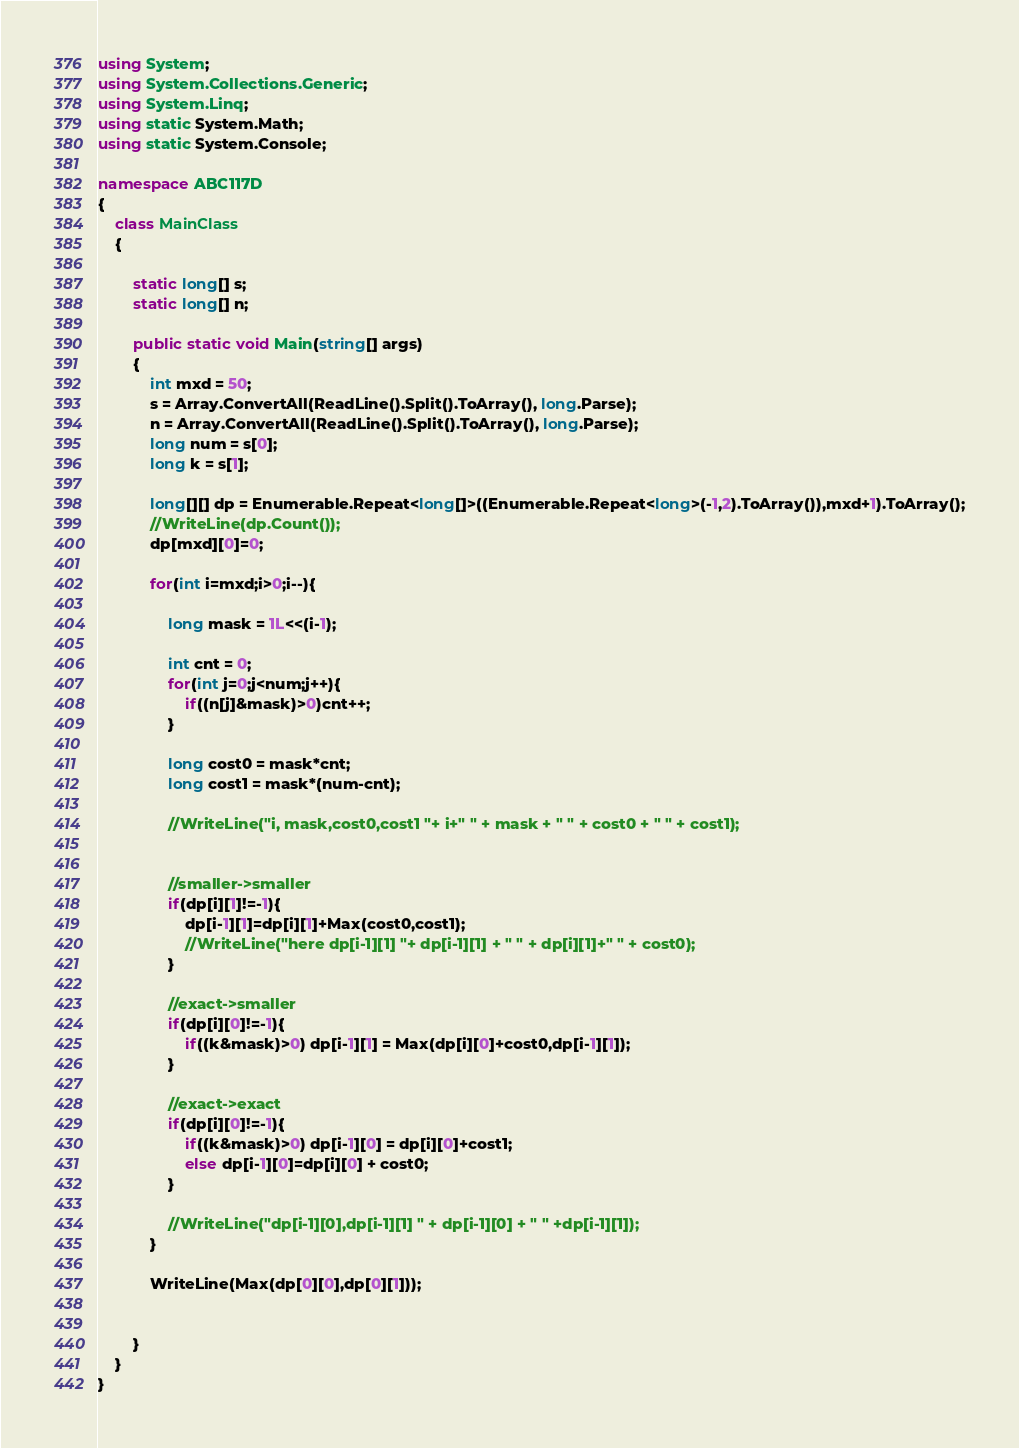<code> <loc_0><loc_0><loc_500><loc_500><_C#_>using System;
using System.Collections.Generic;
using System.Linq;
using static System.Math;
using static System.Console;

namespace ABC117D
{
    class MainClass
    {

        static long[] s;
        static long[] n;

        public static void Main(string[] args)
        {
            int mxd = 50;
            s = Array.ConvertAll(ReadLine().Split().ToArray(), long.Parse);
            n = Array.ConvertAll(ReadLine().Split().ToArray(), long.Parse);
            long num = s[0];
            long k = s[1];

            long[][] dp = Enumerable.Repeat<long[]>((Enumerable.Repeat<long>(-1,2).ToArray()),mxd+1).ToArray();
            //WriteLine(dp.Count());
            dp[mxd][0]=0;

            for(int i=mxd;i>0;i--){
                
                long mask = 1L<<(i-1);

                int cnt = 0;
                for(int j=0;j<num;j++){
                    if((n[j]&mask)>0)cnt++;
                }

                long cost0 = mask*cnt;
                long cost1 = mask*(num-cnt);

                //WriteLine("i, mask,cost0,cost1 "+ i+" " + mask + " " + cost0 + " " + cost1);


                //smaller->smaller
                if(dp[i][1]!=-1){
                    dp[i-1][1]=dp[i][1]+Max(cost0,cost1);
                    //WriteLine("here dp[i-1][1] "+ dp[i-1][1] + " " + dp[i][1]+" " + cost0);
                }

                //exact->smaller
                if(dp[i][0]!=-1){
                    if((k&mask)>0) dp[i-1][1] = Max(dp[i][0]+cost0,dp[i-1][1]);
                }

                //exact->exact
                if(dp[i][0]!=-1){
                    if((k&mask)>0) dp[i-1][0] = dp[i][0]+cost1;
                    else dp[i-1][0]=dp[i][0] + cost0;
                }

                //WriteLine("dp[i-1][0],dp[i-1][1] " + dp[i-1][0] + " " +dp[i-1][1]);
            }

            WriteLine(Max(dp[0][0],dp[0][1]));


        }
    }
}
</code> 